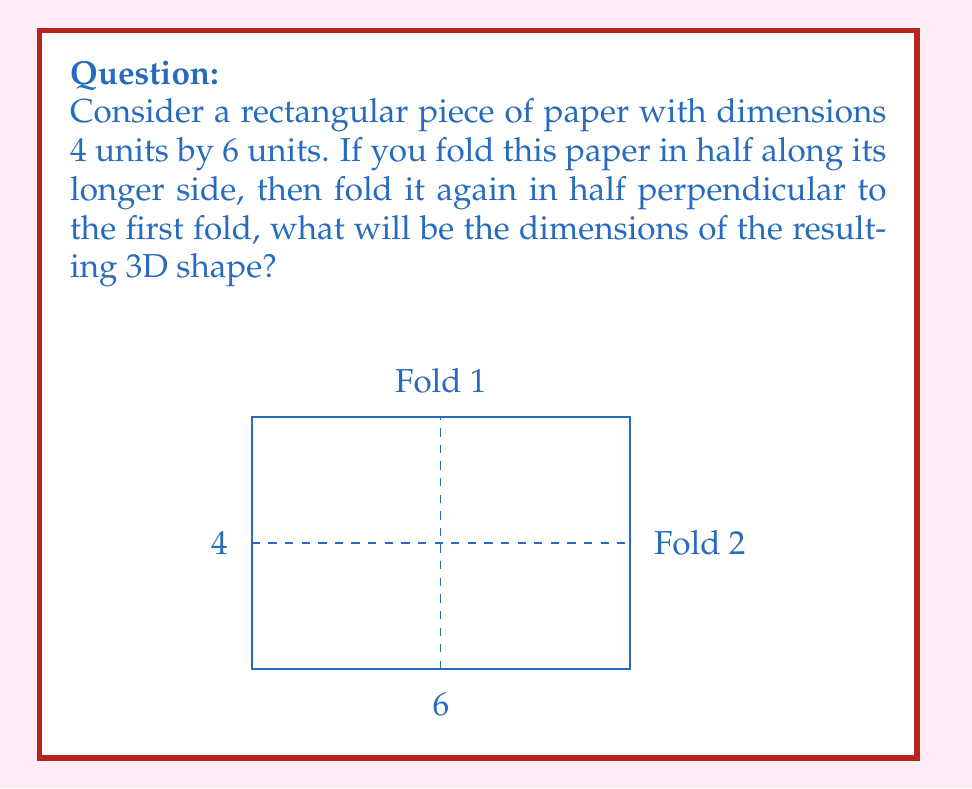Show me your answer to this math problem. Let's approach this step-by-step:

1) Initially, we have a 2D rectangle with dimensions 4 x 6 units.

2) The first fold is along the longer side (6 units). This will halve the longer dimension:
   $$ 6 \div 2 = 3 \text{ units} $$
   After this fold, we have a rectangle of 4 x 3 units.

3) The second fold is perpendicular to the first, which means it will halve the shorter dimension (4 units):
   $$ 4 \div 2 = 2 \text{ units} $$

4) After both folds, we now have a 3D shape. To determine its dimensions:
   - Length: 3 units (from step 2)
   - Width: 2 units (from step 3)
   - Height: The paper's thickness is now doubled twice, but as it's negligibly thin, we can approximate it to 0 units.

Therefore, the resulting 3D shape is essentially a rectangular prism with dimensions 3 x 2 x 0 units.
Answer: 3 x 2 x 0 units 